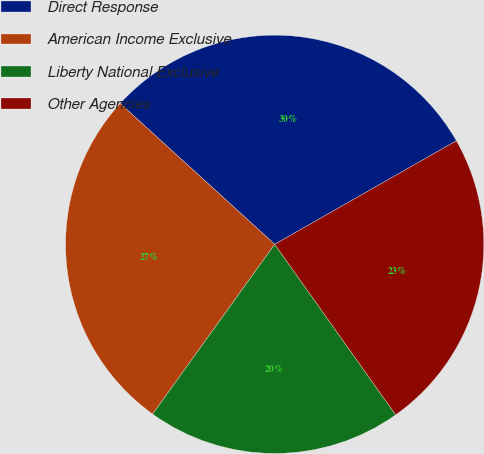Convert chart. <chart><loc_0><loc_0><loc_500><loc_500><pie_chart><fcel>Direct Response<fcel>American Income Exclusive<fcel>Liberty National Exclusive<fcel>Other Agencies<nl><fcel>29.99%<fcel>26.84%<fcel>19.74%<fcel>23.42%<nl></chart> 